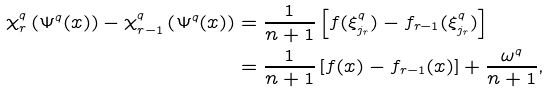<formula> <loc_0><loc_0><loc_500><loc_500>\chi ^ { q } _ { r } \left ( \Psi ^ { q } ( x ) \right ) - \chi ^ { q } _ { r - 1 } \left ( \Psi ^ { q } ( x ) \right ) & = \frac { 1 } { n + 1 } \left [ f ( \xi ^ { q } _ { j _ { r } } ) - f _ { r - 1 } ( \xi ^ { q } _ { j _ { r } } ) \right ] \\ & = \frac { 1 } { n + 1 } \left [ f ( x ) - f _ { r - 1 } ( x ) \right ] + \frac { \omega ^ { q } } { n + 1 } ,</formula> 